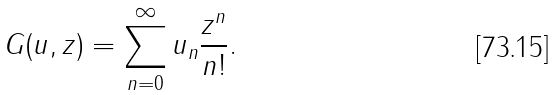Convert formula to latex. <formula><loc_0><loc_0><loc_500><loc_500>G ( u , z ) = \sum _ { n = 0 } ^ { \infty } u _ { n } \frac { z ^ { n } } { n ! } .</formula> 